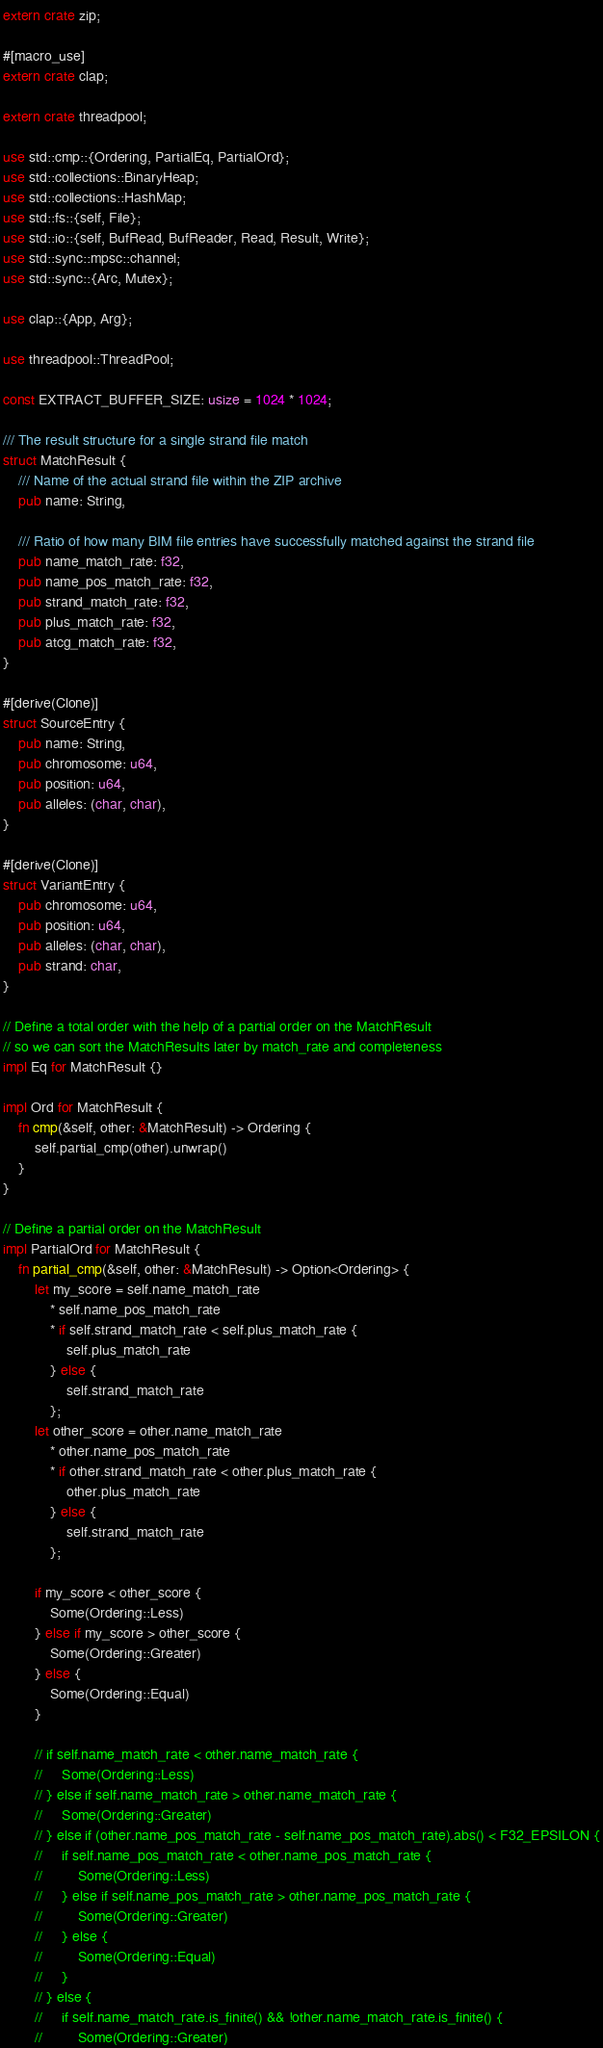Convert code to text. <code><loc_0><loc_0><loc_500><loc_500><_Rust_>extern crate zip;

#[macro_use]
extern crate clap;

extern crate threadpool;

use std::cmp::{Ordering, PartialEq, PartialOrd};
use std::collections::BinaryHeap;
use std::collections::HashMap;
use std::fs::{self, File};
use std::io::{self, BufRead, BufReader, Read, Result, Write};
use std::sync::mpsc::channel;
use std::sync::{Arc, Mutex};

use clap::{App, Arg};

use threadpool::ThreadPool;

const EXTRACT_BUFFER_SIZE: usize = 1024 * 1024;

/// The result structure for a single strand file match
struct MatchResult {
    /// Name of the actual strand file within the ZIP archive
    pub name: String,

    /// Ratio of how many BIM file entries have successfully matched against the strand file
    pub name_match_rate: f32,
    pub name_pos_match_rate: f32,
    pub strand_match_rate: f32,
    pub plus_match_rate: f32,
    pub atcg_match_rate: f32,
}

#[derive(Clone)]
struct SourceEntry {
    pub name: String,
    pub chromosome: u64,
    pub position: u64,
    pub alleles: (char, char),
}

#[derive(Clone)]
struct VariantEntry {
    pub chromosome: u64,
    pub position: u64,
    pub alleles: (char, char),
    pub strand: char,
}

// Define a total order with the help of a partial order on the MatchResult
// so we can sort the MatchResults later by match_rate and completeness
impl Eq for MatchResult {}

impl Ord for MatchResult {
    fn cmp(&self, other: &MatchResult) -> Ordering {
        self.partial_cmp(other).unwrap()
    }
}

// Define a partial order on the MatchResult
impl PartialOrd for MatchResult {
    fn partial_cmp(&self, other: &MatchResult) -> Option<Ordering> {
        let my_score = self.name_match_rate
            * self.name_pos_match_rate
            * if self.strand_match_rate < self.plus_match_rate {
                self.plus_match_rate
            } else {
                self.strand_match_rate
            };
        let other_score = other.name_match_rate
            * other.name_pos_match_rate
            * if other.strand_match_rate < other.plus_match_rate {
                other.plus_match_rate
            } else {
                self.strand_match_rate
            };

        if my_score < other_score {
            Some(Ordering::Less)
        } else if my_score > other_score {
            Some(Ordering::Greater)
        } else {
            Some(Ordering::Equal)
        }

        // if self.name_match_rate < other.name_match_rate {
        //     Some(Ordering::Less)
        // } else if self.name_match_rate > other.name_match_rate {
        //     Some(Ordering::Greater)
        // } else if (other.name_pos_match_rate - self.name_pos_match_rate).abs() < F32_EPSILON {
        //     if self.name_pos_match_rate < other.name_pos_match_rate {
        //         Some(Ordering::Less)
        //     } else if self.name_pos_match_rate > other.name_pos_match_rate {
        //         Some(Ordering::Greater)
        //     } else {
        //         Some(Ordering::Equal)
        //     }
        // } else {
        //     if self.name_match_rate.is_finite() && !other.name_match_rate.is_finite() {
        //         Some(Ordering::Greater)</code> 